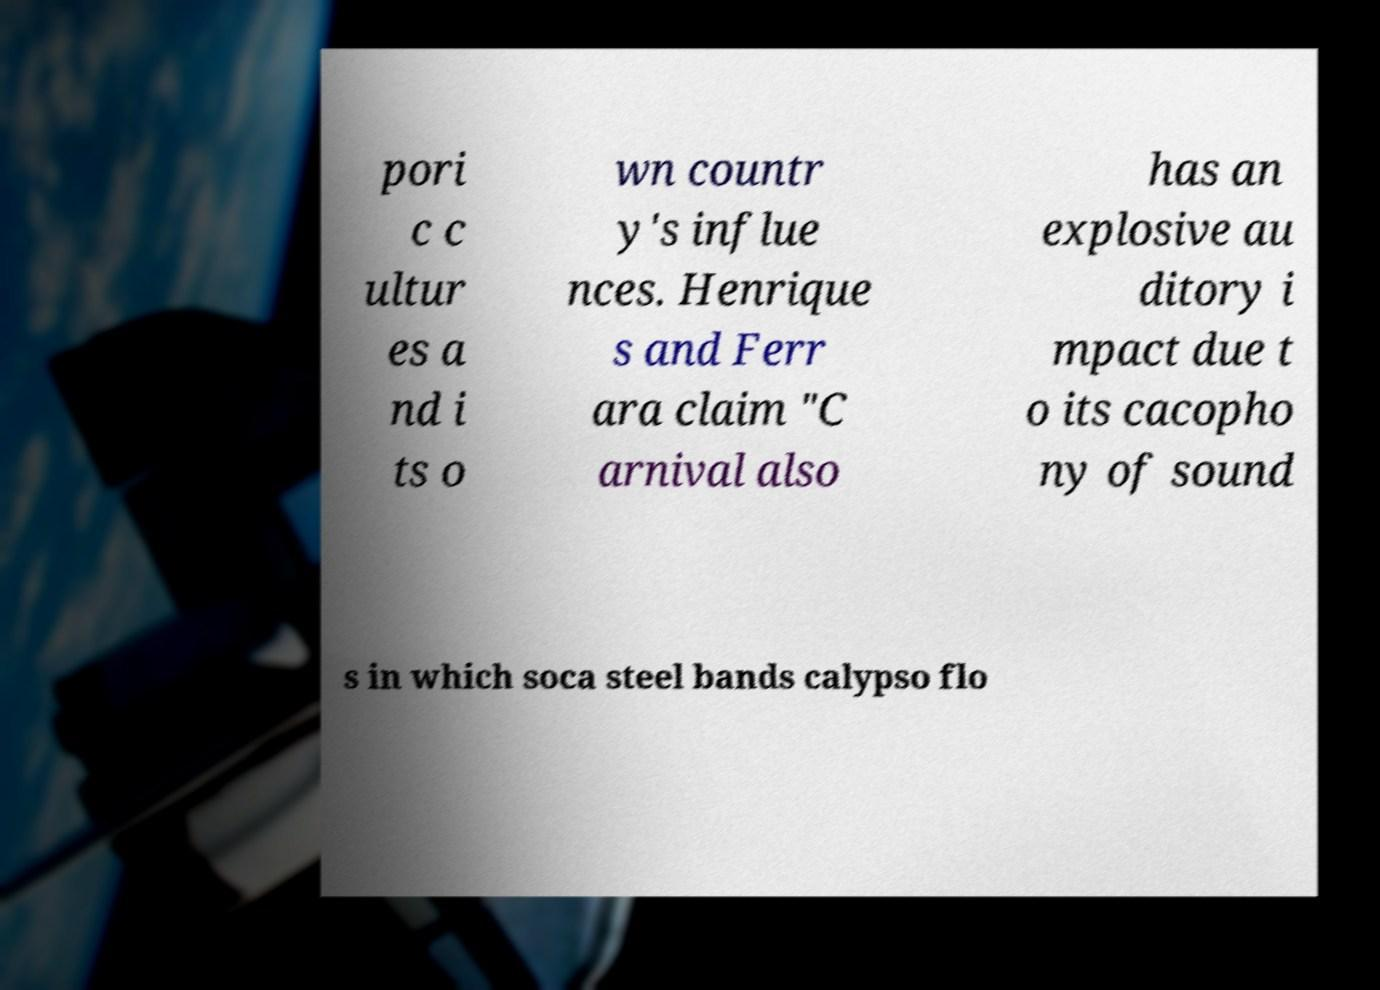For documentation purposes, I need the text within this image transcribed. Could you provide that? pori c c ultur es a nd i ts o wn countr y's influe nces. Henrique s and Ferr ara claim "C arnival also has an explosive au ditory i mpact due t o its cacopho ny of sound s in which soca steel bands calypso flo 